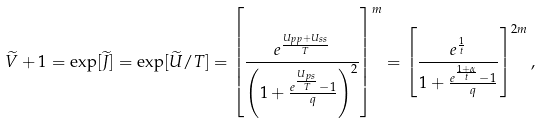<formula> <loc_0><loc_0><loc_500><loc_500>\widetilde { V } + 1 = \exp [ \widetilde { J } ] = \exp [ \widetilde { U } / T ] = \left [ { \frac { e ^ { \frac { U _ { p p } + U _ { s s } } { T } } } { \left ( 1 + \frac { e ^ { \frac { U _ { p s } } { T } } - 1 } { q } \right ) ^ { 2 } } } \right ] ^ { m } = \left [ { \frac { e ^ { \frac { 1 } { t } } } { 1 + \frac { e ^ { \frac { 1 + \alpha } { t } } - 1 } { q } } } \right ] ^ { 2 m } ,</formula> 